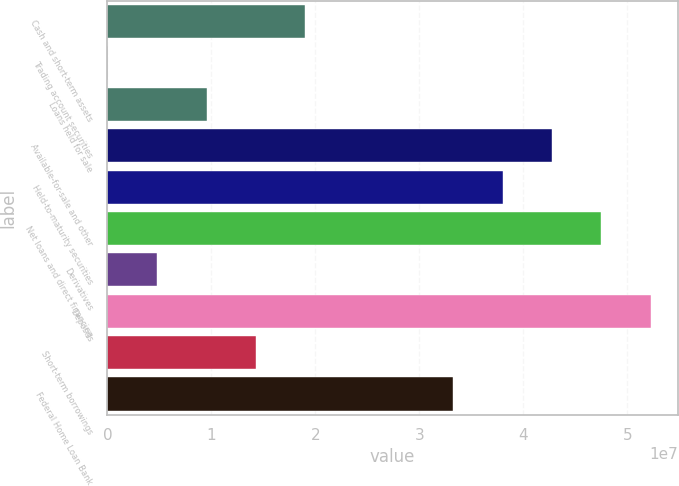Convert chart to OTSL. <chart><loc_0><loc_0><loc_500><loc_500><bar_chart><fcel>Cash and short-term assets<fcel>Trading account securities<fcel>Loans held for sale<fcel>Available-for-sale and other<fcel>Held-to-maturity securities<fcel>Net loans and direct financing<fcel>Derivatives<fcel>Deposits<fcel>Short-term borrowings<fcel>Federal Home Loan Bank<nl><fcel>1.9024e+07<fcel>35573<fcel>9.5298e+06<fcel>4.27596e+07<fcel>3.80125e+07<fcel>4.75067e+07<fcel>4.78269e+06<fcel>5.22538e+07<fcel>1.42769e+07<fcel>3.32654e+07<nl></chart> 